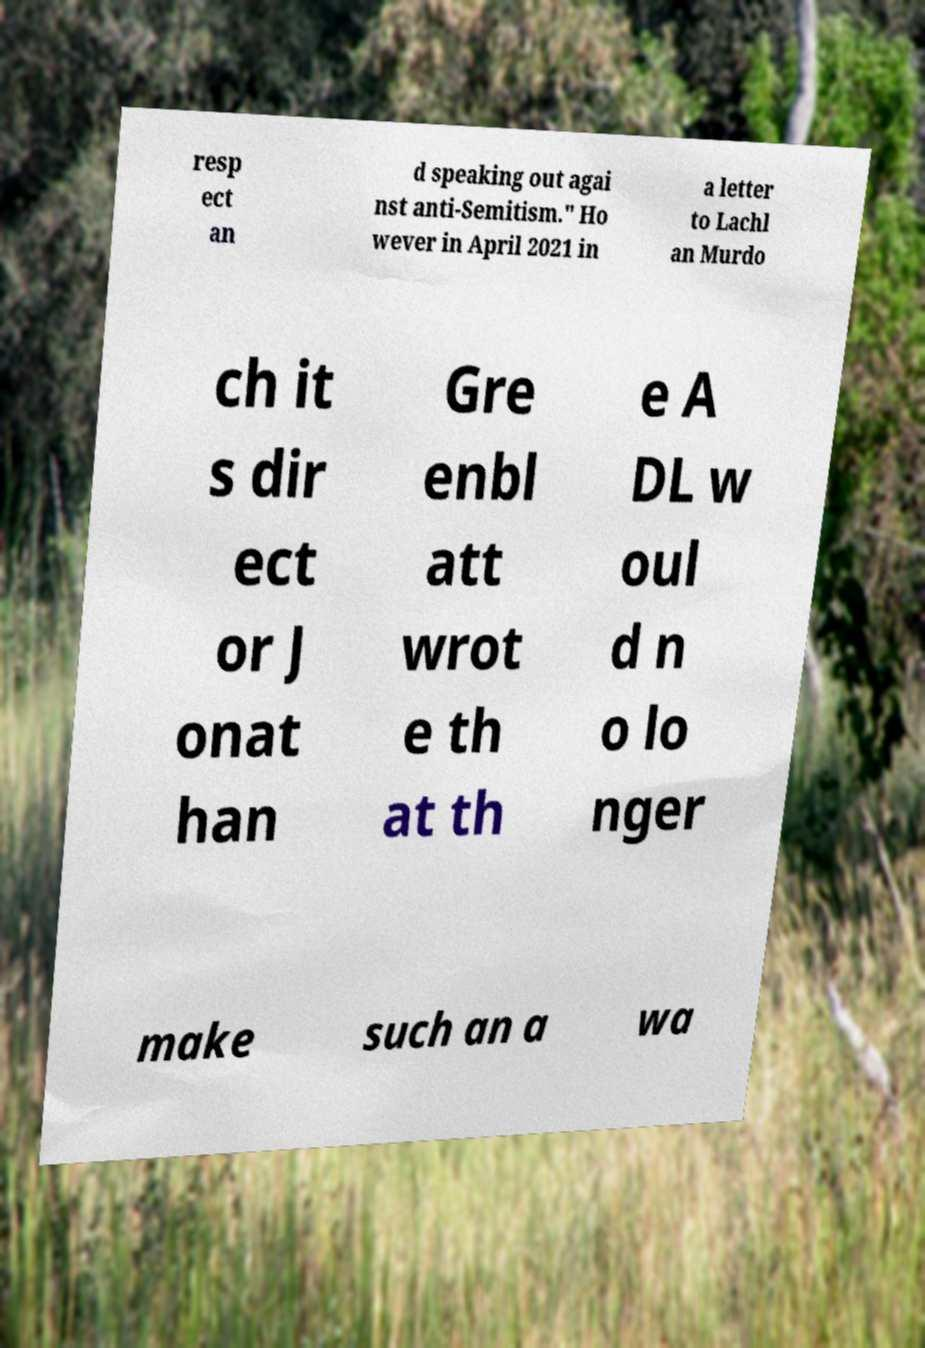Could you extract and type out the text from this image? resp ect an d speaking out agai nst anti-Semitism." Ho wever in April 2021 in a letter to Lachl an Murdo ch it s dir ect or J onat han Gre enbl att wrot e th at th e A DL w oul d n o lo nger make such an a wa 